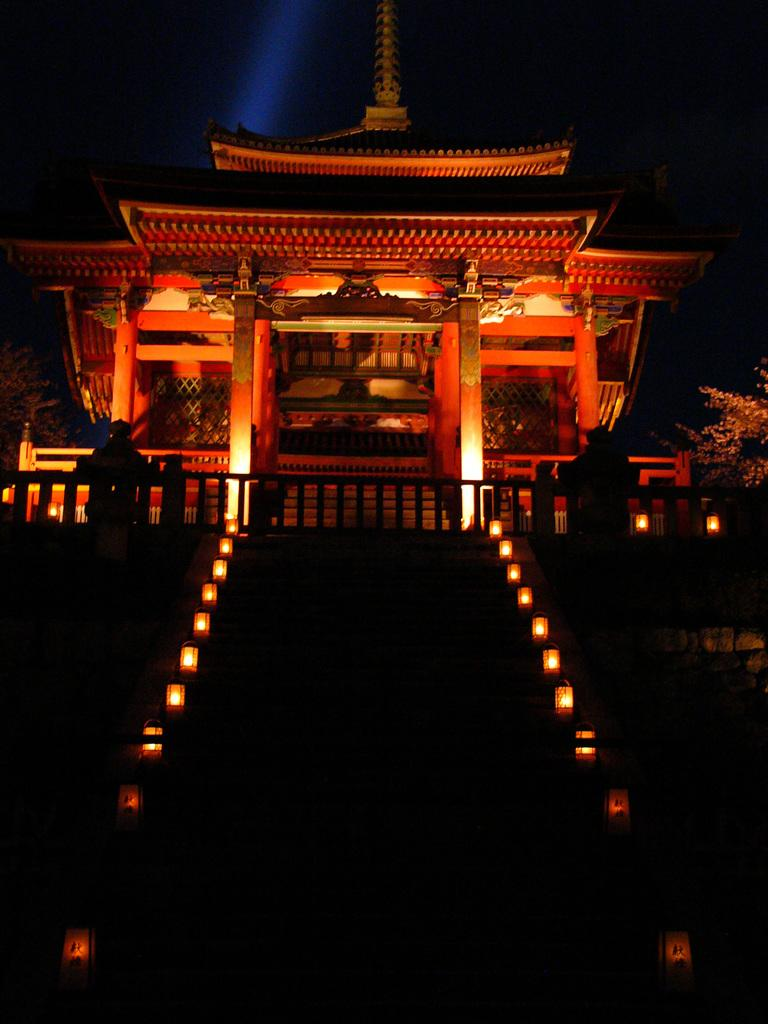What is the main structure in the center of the image? There is a building in the center of the image. What can be seen in the center of the image besides the building? There are lights in the center of the image. What architectural feature is present at the bottom of the image? There are stairs at the bottom of the image. What else can be seen at the bottom of the image? There are lights at the bottom of the image. What type of vegetation is present on both sides of the image? There are plants on the right side of the image and plants on the left side of the image. What is the price of the mom's desire in the image? There is no reference to a mom or a desire in the image, so it is not possible to determine a price. 